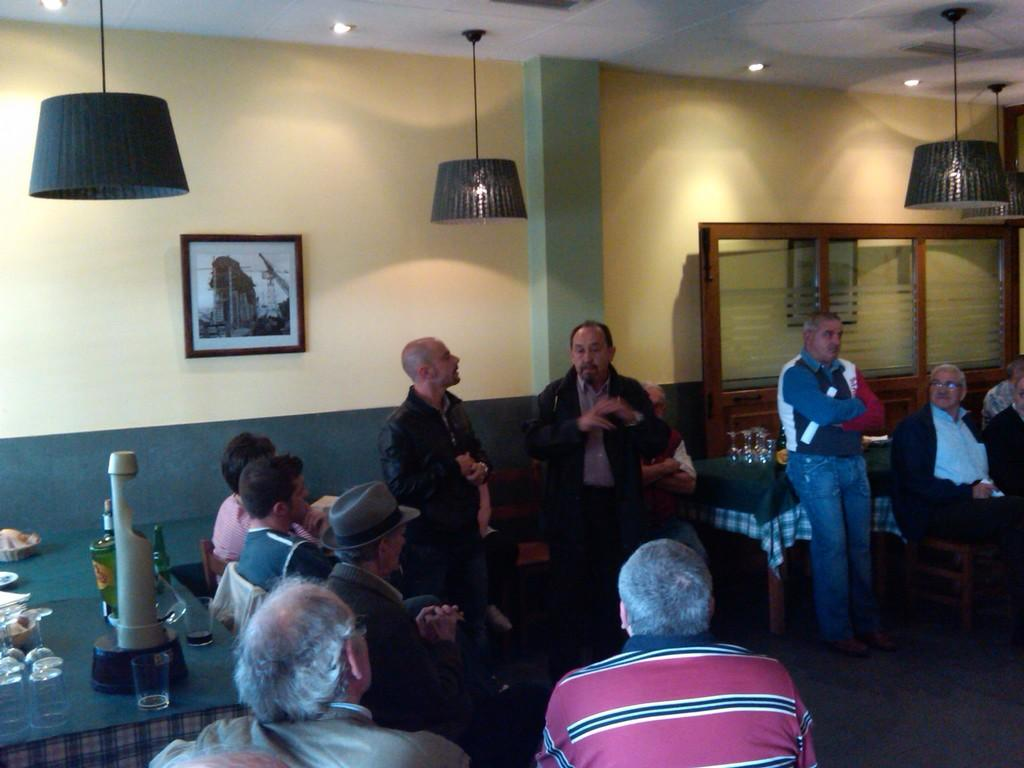What are the people in the image doing? There are people sitting on chairs and standing in the image. Can you describe the positions of the people in the image? Some people are sitting on chairs, while others are standing. What type of soap is being used by the people in the image? There is no soap present in the image; it features people sitting on chairs and standing. How does the expansion of the universe affect the people in the image? The expansion of the universe does not affect the people in the image, as it is not depicted or mentioned in the image. 